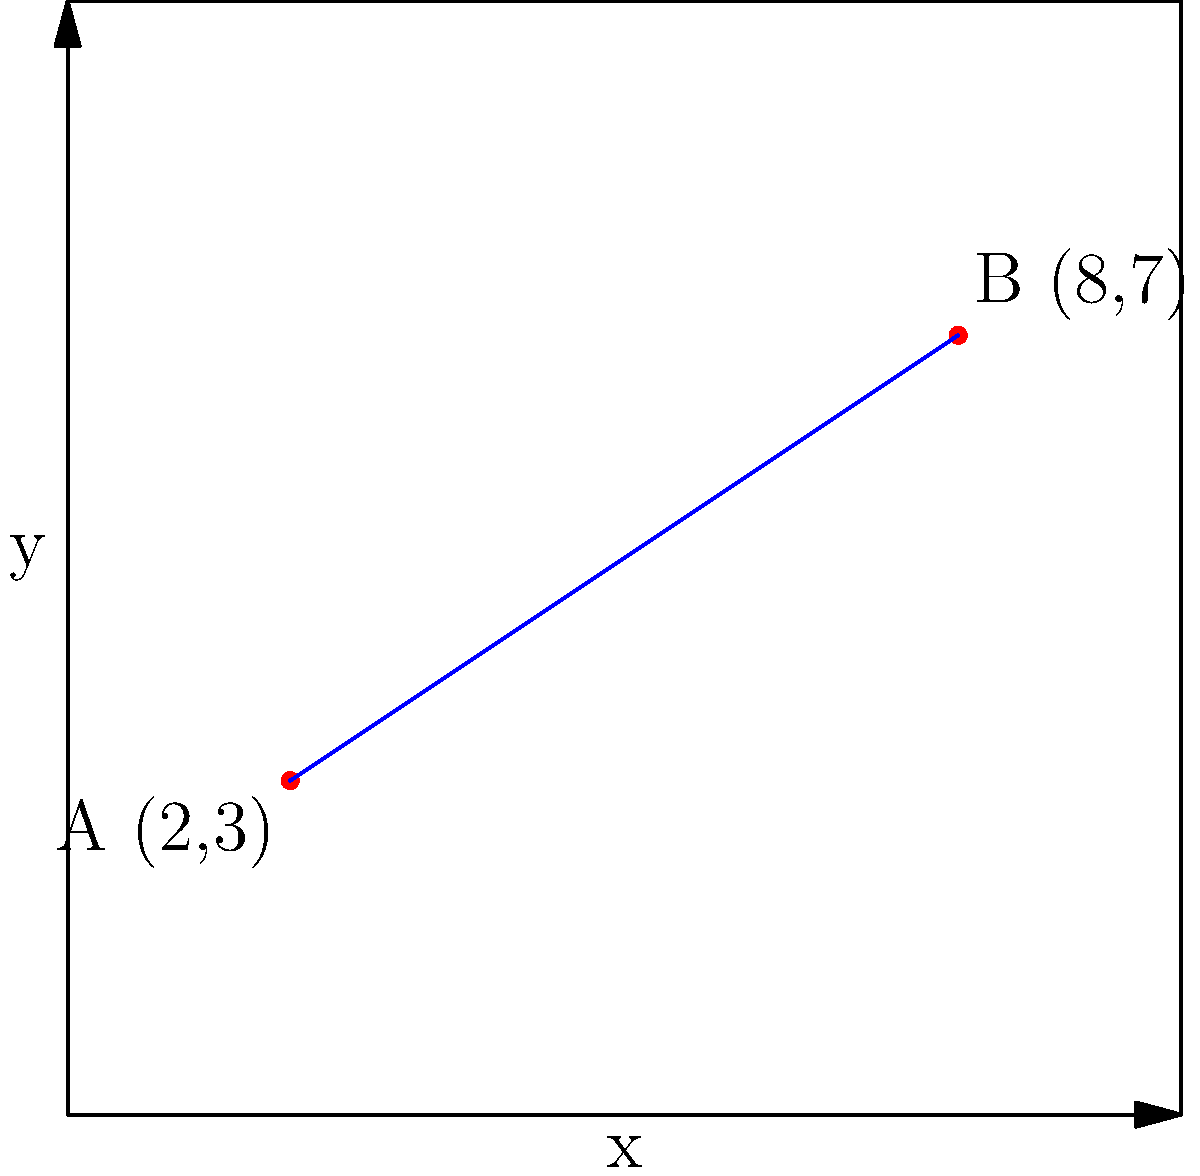In a city's new public safety initiative, two patrol points A(2,3) and B(8,7) are established on a coordinate grid representing the urban area. To maximize coverage, a third patrol point C needs to be positioned such that it forms an equilateral triangle with A and B. What are the coordinates of point C to the nearest tenth? To solve this problem, we'll follow these steps:

1) First, calculate the distance between A and B:
   $d = \sqrt{(x_2-x_1)^2 + (y_2-y_1)^2} = \sqrt{(8-2)^2 + (7-3)^2} = \sqrt{36 + 16} = \sqrt{52} = 7.21$ units

2) The center of the equilateral triangle will be the midpoint of AB:
   $M_x = \frac{x_A + x_B}{2} = \frac{2 + 8}{2} = 5$
   $M_y = \frac{y_A + y_B}{2} = \frac{3 + 7}{2} = 5$
   So, M(5,5)

3) The height of the equilateral triangle is:
   $h = \frac{\sqrt{3}}{2} * 7.21 = 6.24$ units

4) The vector from M to C is perpendicular to AB and has length $\frac{1}{3}h$:
   $\vec{AB} = (6,4)$
   Perpendicular vector: $\vec{v} = (-4,6)$
   Normalized: $\vec{u} = \frac{\vec{v}}{|\vec{v}|} = \frac{(-4,6)}{\sqrt{52}} = (-0.5547, 0.8321)$

5) Point C is located at:
   $C_x = M_x + \frac{1}{3}h * u_x = 5 + \frac{1}{3} * 6.24 * (-0.5547) = 3.8$
   $C_y = M_y + \frac{1}{3}h * u_y = 5 + \frac{1}{3} * 6.24 * 0.8321 = 6.7$

Therefore, the coordinates of point C are approximately (3.8, 6.7).
Answer: (3.8, 6.7) 